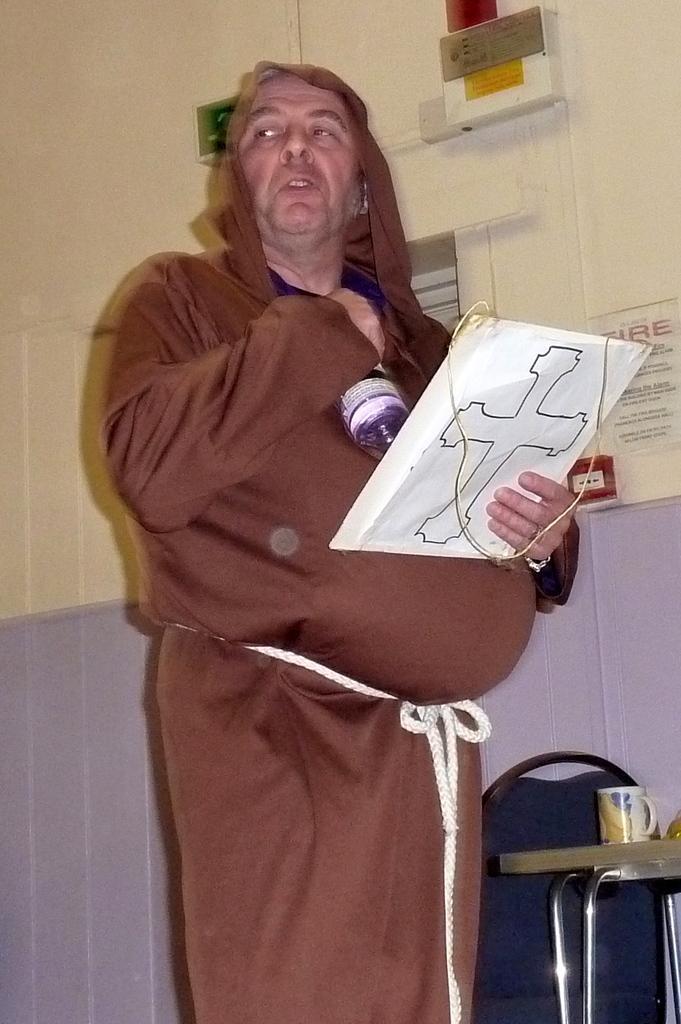How would you summarize this image in a sentence or two? In this picture we can observe a person wearing a brown color dress. We can observe a rope around his belly. He is holding a paper in his hands. On the right side there is a table on which we can observe a glass. There is a blue color chair. In the background there is a wall. 